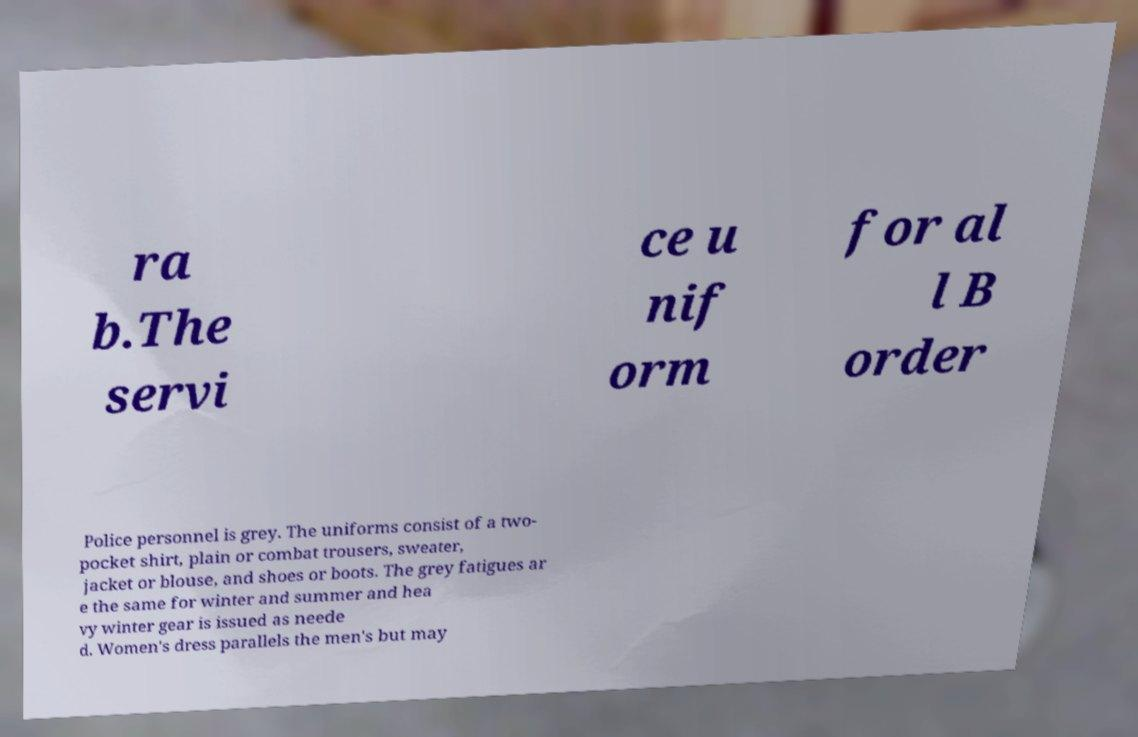Please identify and transcribe the text found in this image. ra b.The servi ce u nif orm for al l B order Police personnel is grey. The uniforms consist of a two- pocket shirt, plain or combat trousers, sweater, jacket or blouse, and shoes or boots. The grey fatigues ar e the same for winter and summer and hea vy winter gear is issued as neede d. Women's dress parallels the men's but may 